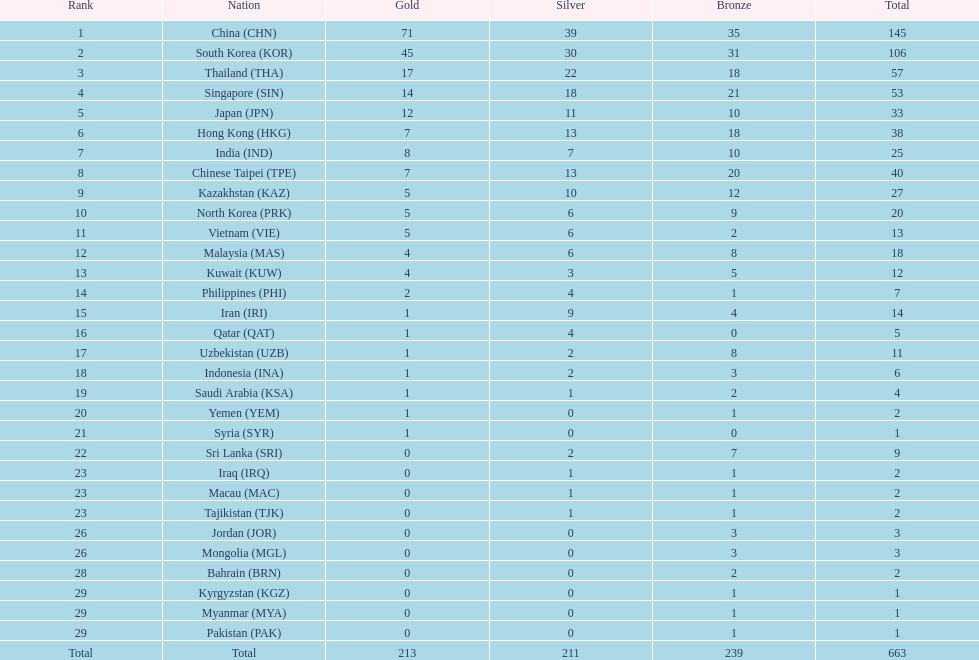How does the total medal count for qatar and indonesia differ? 1. Would you be able to parse every entry in this table? {'header': ['Rank', 'Nation', 'Gold', 'Silver', 'Bronze', 'Total'], 'rows': [['1', 'China\xa0(CHN)', '71', '39', '35', '145'], ['2', 'South Korea\xa0(KOR)', '45', '30', '31', '106'], ['3', 'Thailand\xa0(THA)', '17', '22', '18', '57'], ['4', 'Singapore\xa0(SIN)', '14', '18', '21', '53'], ['5', 'Japan\xa0(JPN)', '12', '11', '10', '33'], ['6', 'Hong Kong\xa0(HKG)', '7', '13', '18', '38'], ['7', 'India\xa0(IND)', '8', '7', '10', '25'], ['8', 'Chinese Taipei\xa0(TPE)', '7', '13', '20', '40'], ['9', 'Kazakhstan\xa0(KAZ)', '5', '10', '12', '27'], ['10', 'North Korea\xa0(PRK)', '5', '6', '9', '20'], ['11', 'Vietnam\xa0(VIE)', '5', '6', '2', '13'], ['12', 'Malaysia\xa0(MAS)', '4', '6', '8', '18'], ['13', 'Kuwait\xa0(KUW)', '4', '3', '5', '12'], ['14', 'Philippines\xa0(PHI)', '2', '4', '1', '7'], ['15', 'Iran\xa0(IRI)', '1', '9', '4', '14'], ['16', 'Qatar\xa0(QAT)', '1', '4', '0', '5'], ['17', 'Uzbekistan\xa0(UZB)', '1', '2', '8', '11'], ['18', 'Indonesia\xa0(INA)', '1', '2', '3', '6'], ['19', 'Saudi Arabia\xa0(KSA)', '1', '1', '2', '4'], ['20', 'Yemen\xa0(YEM)', '1', '0', '1', '2'], ['21', 'Syria\xa0(SYR)', '1', '0', '0', '1'], ['22', 'Sri Lanka\xa0(SRI)', '0', '2', '7', '9'], ['23', 'Iraq\xa0(IRQ)', '0', '1', '1', '2'], ['23', 'Macau\xa0(MAC)', '0', '1', '1', '2'], ['23', 'Tajikistan\xa0(TJK)', '0', '1', '1', '2'], ['26', 'Jordan\xa0(JOR)', '0', '0', '3', '3'], ['26', 'Mongolia\xa0(MGL)', '0', '0', '3', '3'], ['28', 'Bahrain\xa0(BRN)', '0', '0', '2', '2'], ['29', 'Kyrgyzstan\xa0(KGZ)', '0', '0', '1', '1'], ['29', 'Myanmar\xa0(MYA)', '0', '0', '1', '1'], ['29', 'Pakistan\xa0(PAK)', '0', '0', '1', '1'], ['Total', 'Total', '213', '211', '239', '663']]} 